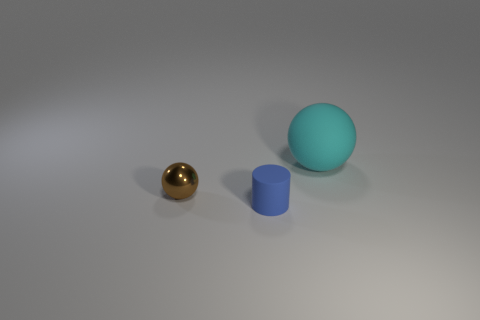Add 1 rubber cylinders. How many objects exist? 4 Subtract all cylinders. How many objects are left? 2 Subtract all yellow cylinders. Subtract all big cyan matte balls. How many objects are left? 2 Add 1 blue objects. How many blue objects are left? 2 Add 1 blue rubber things. How many blue rubber things exist? 2 Subtract 0 red spheres. How many objects are left? 3 Subtract all yellow cylinders. Subtract all purple spheres. How many cylinders are left? 1 